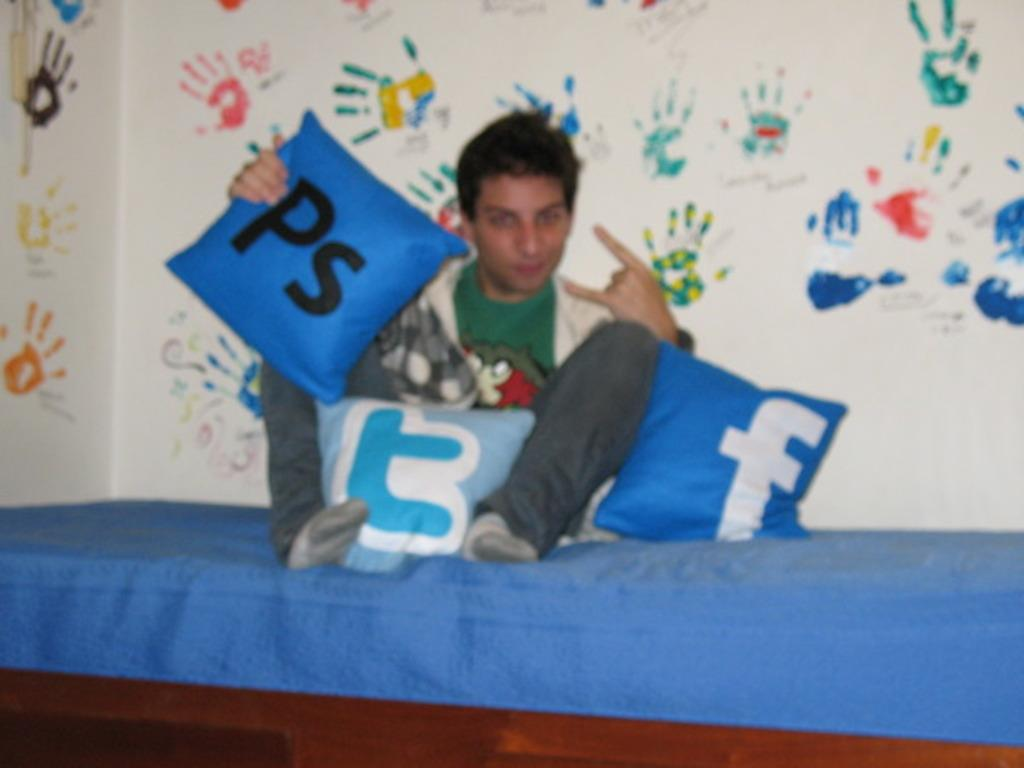<image>
Provide a brief description of the given image. a Facebook logo that is on a blue pillow 